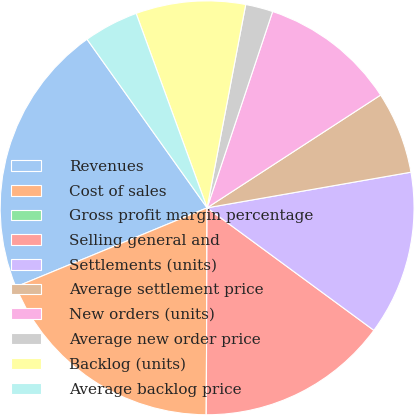Convert chart. <chart><loc_0><loc_0><loc_500><loc_500><pie_chart><fcel>Revenues<fcel>Cost of sales<fcel>Gross profit margin percentage<fcel>Selling general and<fcel>Settlements (units)<fcel>Average settlement price<fcel>New orders (units)<fcel>Average new order price<fcel>Backlog (units)<fcel>Average backlog price<nl><fcel>21.39%<fcel>18.7%<fcel>0.0%<fcel>14.98%<fcel>12.84%<fcel>6.42%<fcel>10.7%<fcel>2.14%<fcel>8.56%<fcel>4.28%<nl></chart> 